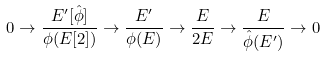Convert formula to latex. <formula><loc_0><loc_0><loc_500><loc_500>0 \to \frac { E ^ { \prime } [ \hat { \phi } ] } { \phi ( E [ 2 ] ) } \to \frac { E ^ { \prime } } { \phi ( E ) } \to \frac { E } { 2 E } \to \frac { E } { \hat { \phi } ( E ^ { \prime } ) } \to 0</formula> 